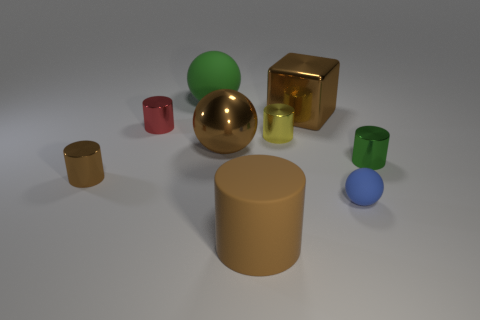Subtract all small yellow cylinders. How many cylinders are left? 4 Subtract 2 cylinders. How many cylinders are left? 3 Subtract all yellow cylinders. How many cylinders are left? 4 Subtract all blue cylinders. Subtract all brown balls. How many cylinders are left? 5 Add 1 small yellow metallic cubes. How many objects exist? 10 Subtract all spheres. How many objects are left? 6 Add 7 yellow shiny objects. How many yellow shiny objects are left? 8 Add 3 brown rubber cylinders. How many brown rubber cylinders exist? 4 Subtract 0 gray blocks. How many objects are left? 9 Subtract all big red rubber things. Subtract all small balls. How many objects are left? 8 